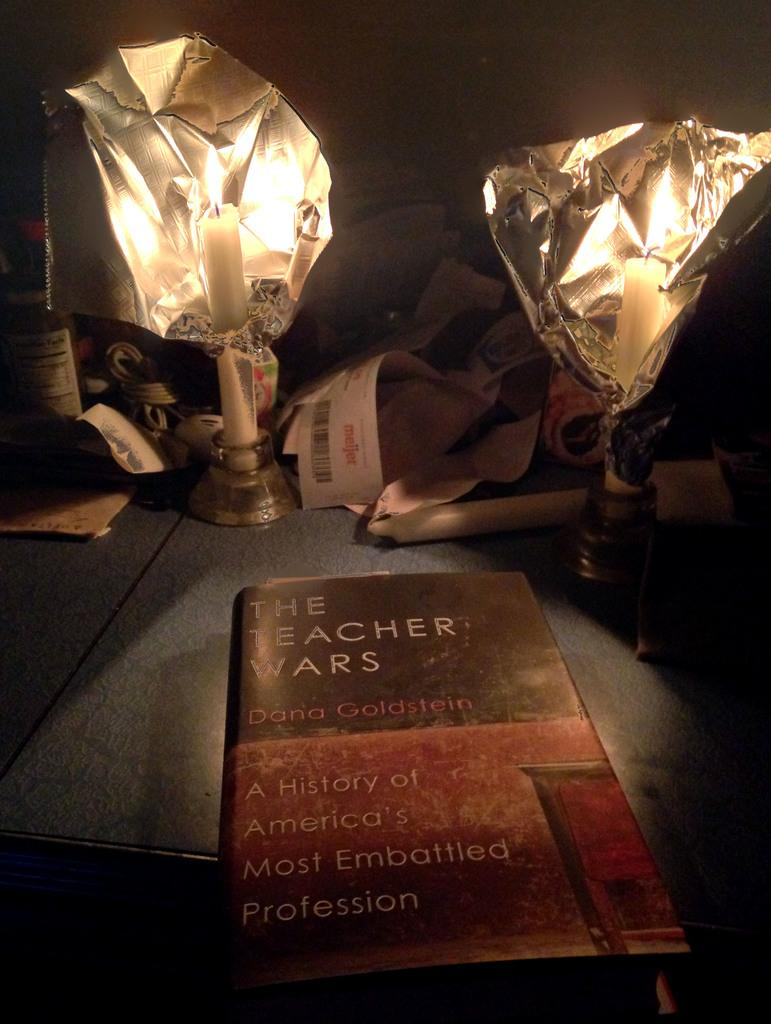Provide a one-sentence caption for the provided image. A book about the difficult world of education is titled The Teacher Wars. 